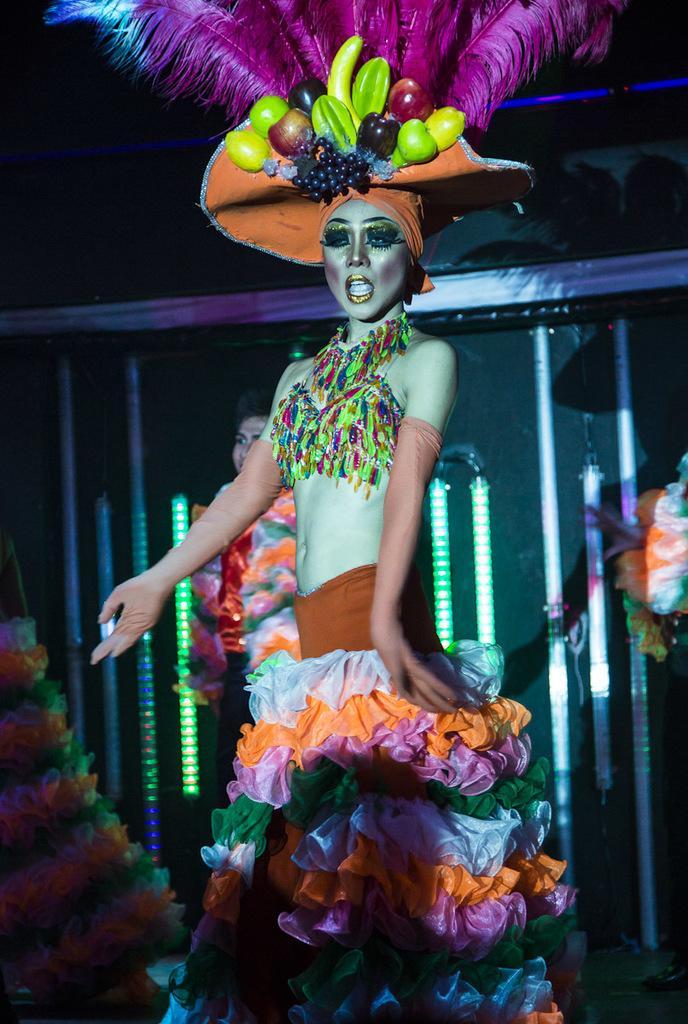Please provide a concise description of this image. In the center of the image a lady is standing and wearing a hat. In the background of the image we can see a wall and lights are present. 